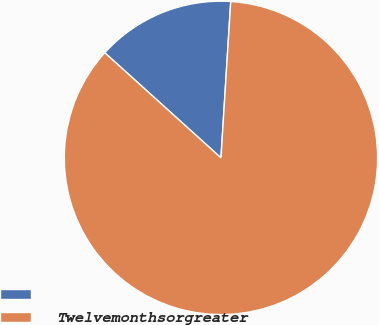Convert chart. <chart><loc_0><loc_0><loc_500><loc_500><pie_chart><ecel><fcel>Twelvemonthsorgreater<nl><fcel>14.29%<fcel>85.71%<nl></chart> 